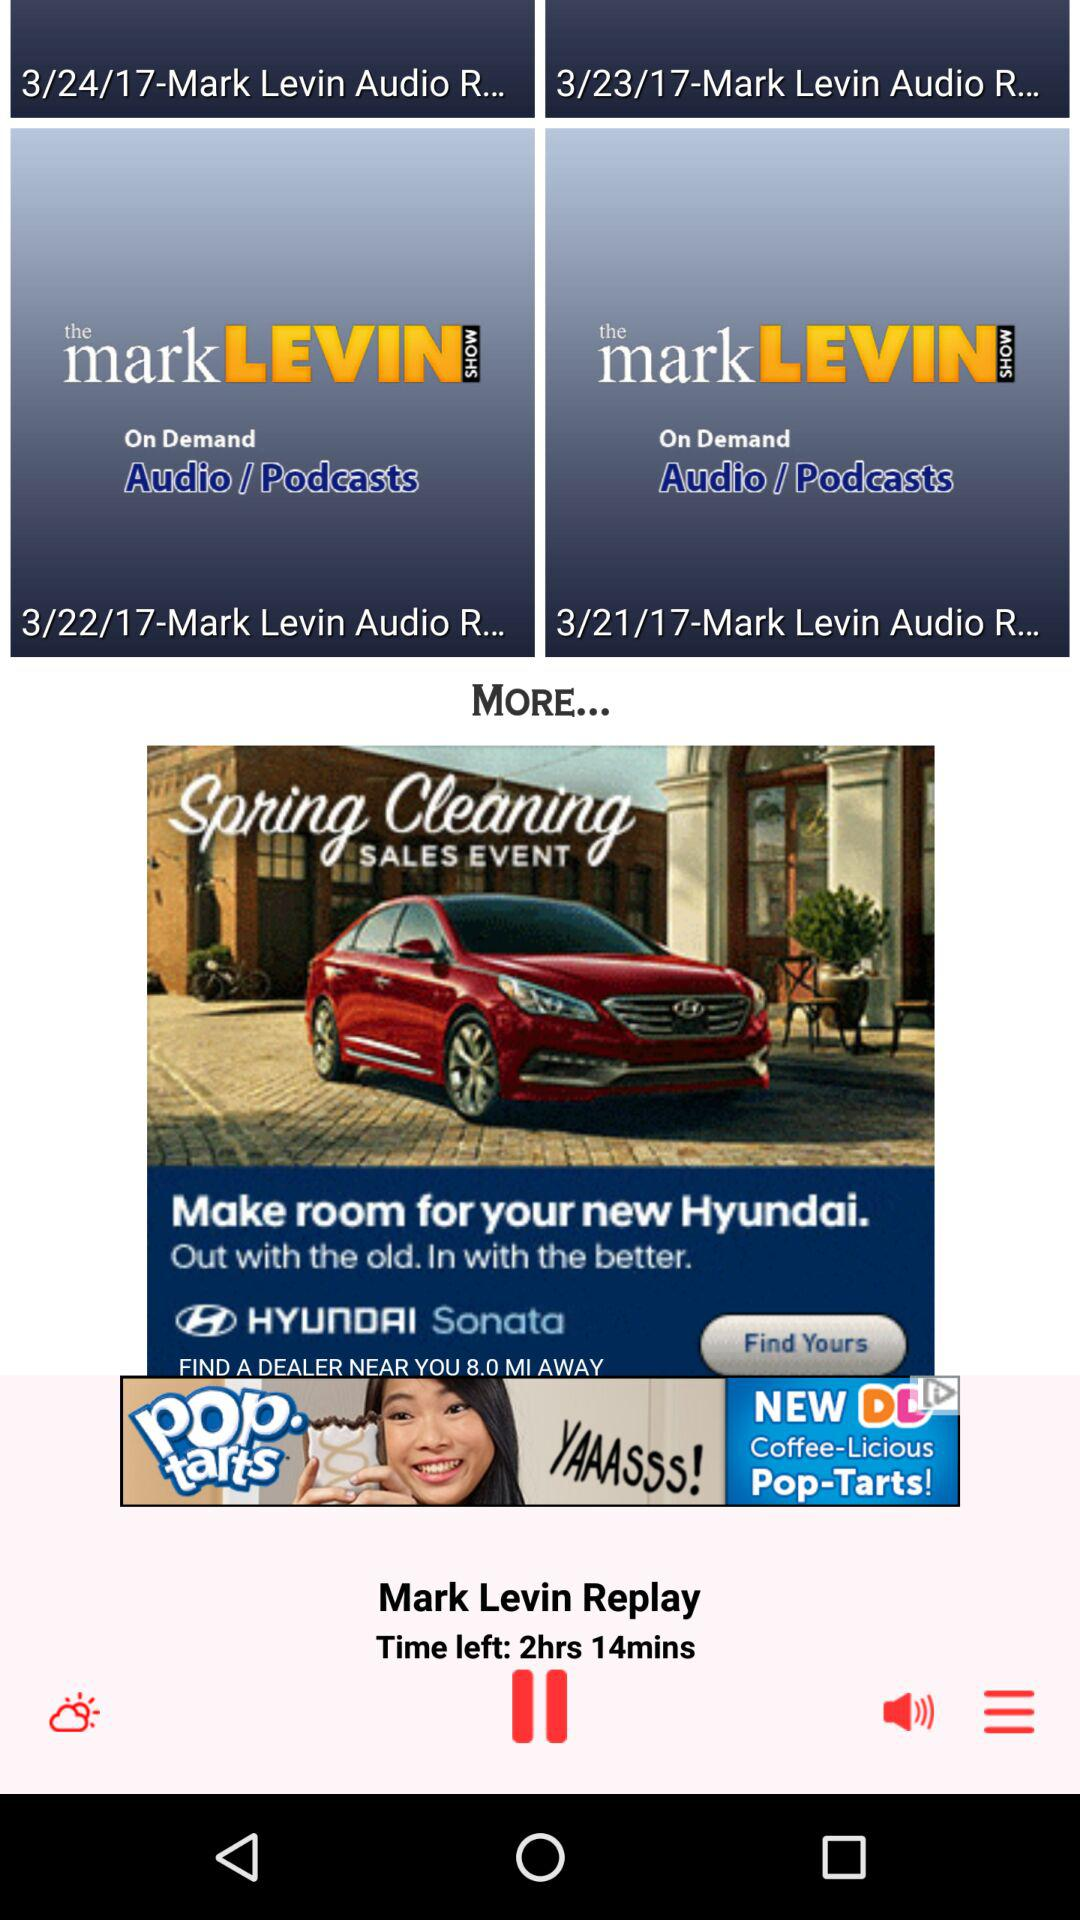How many minutes are left in the current podcast?
Answer the question using a single word or phrase. 14 